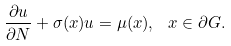Convert formula to latex. <formula><loc_0><loc_0><loc_500><loc_500>\frac { \partial u } { \partial N } + \sigma ( x ) u = \mu ( x ) , \ x \in \partial G .</formula> 